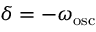Convert formula to latex. <formula><loc_0><loc_0><loc_500><loc_500>\delta = - \omega _ { o s c }</formula> 